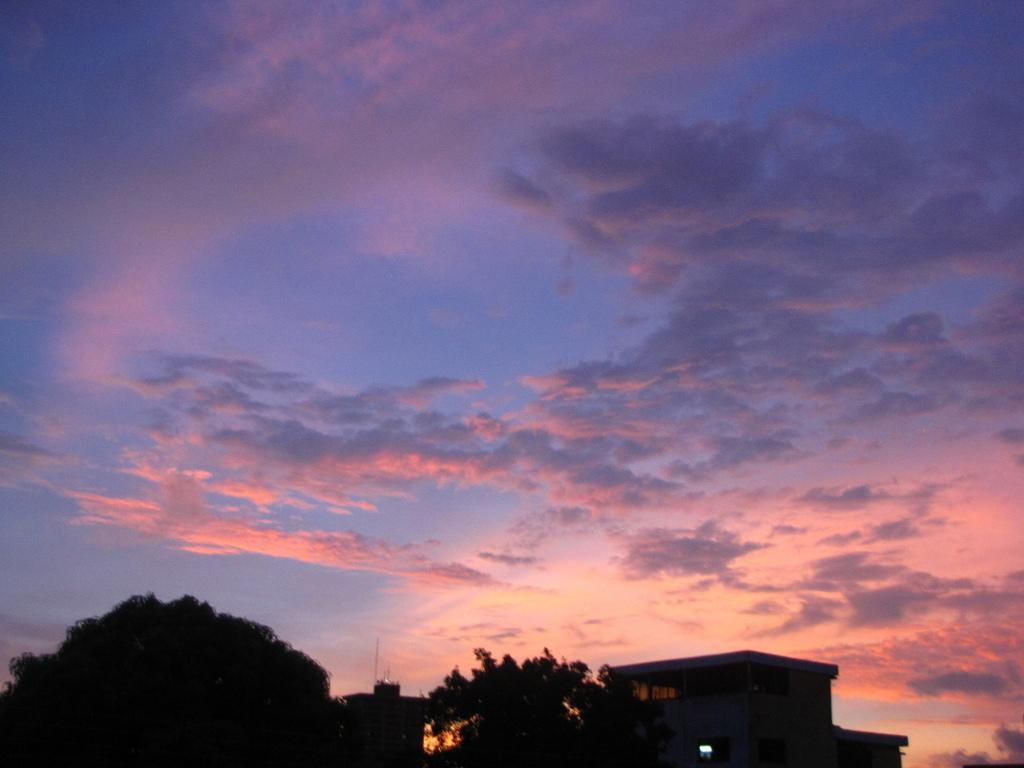What type of structure is present in the image? There is a building in the image. What other natural elements can be seen in the image? There are trees in the image. Are there any artificial light sources visible in the image? Yes, there are lights in the image. What is visible at the top of the image? The sky is visible at the top of the image. How would you describe the sky's condition in the image? The sky appears to be cloudy in the image. What type of ornament is hanging from the building in the image? There is no ornament hanging from the building in the image. Can you tell me which store is located in the building in the image? The image does not provide information about any specific store in the building. Who is the judge presiding over the case in the image? There is no judge or case depicted in the image. 